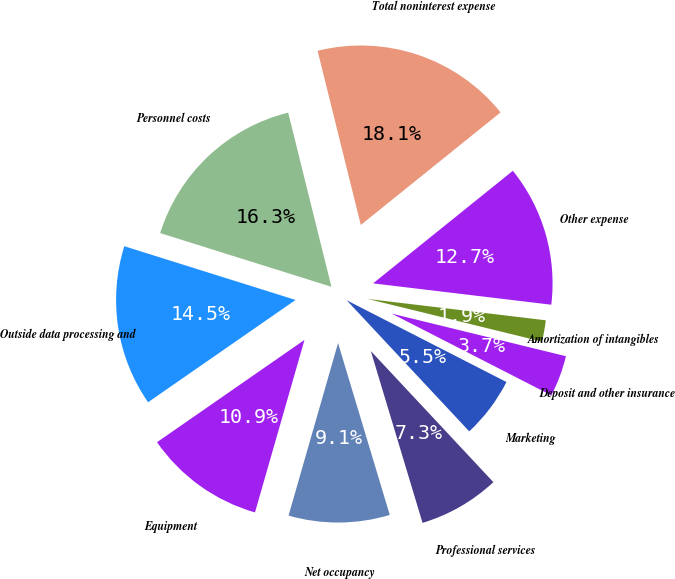Convert chart to OTSL. <chart><loc_0><loc_0><loc_500><loc_500><pie_chart><fcel>Personnel costs<fcel>Outside data processing and<fcel>Equipment<fcel>Net occupancy<fcel>Professional services<fcel>Marketing<fcel>Deposit and other insurance<fcel>Amortization of intangibles<fcel>Other expense<fcel>Total noninterest expense<nl><fcel>16.29%<fcel>14.49%<fcel>10.9%<fcel>9.1%<fcel>7.31%<fcel>5.51%<fcel>3.71%<fcel>1.92%<fcel>12.69%<fcel>18.08%<nl></chart> 